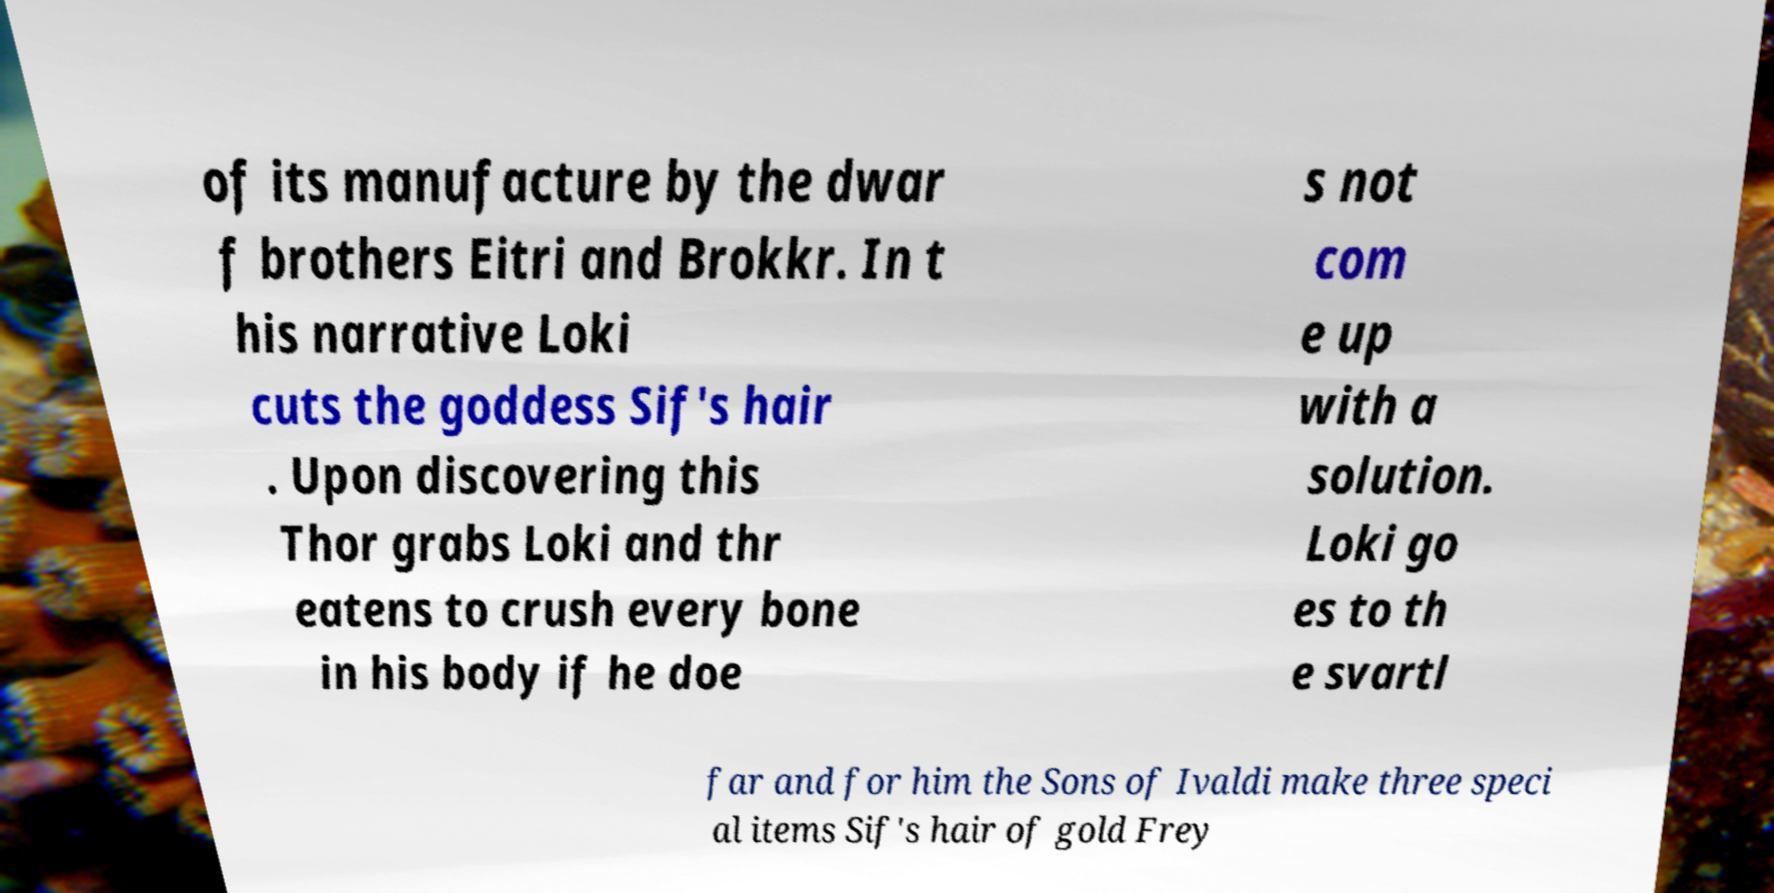What messages or text are displayed in this image? I need them in a readable, typed format. of its manufacture by the dwar f brothers Eitri and Brokkr. In t his narrative Loki cuts the goddess Sif's hair . Upon discovering this Thor grabs Loki and thr eatens to crush every bone in his body if he doe s not com e up with a solution. Loki go es to th e svartl far and for him the Sons of Ivaldi make three speci al items Sif's hair of gold Frey 